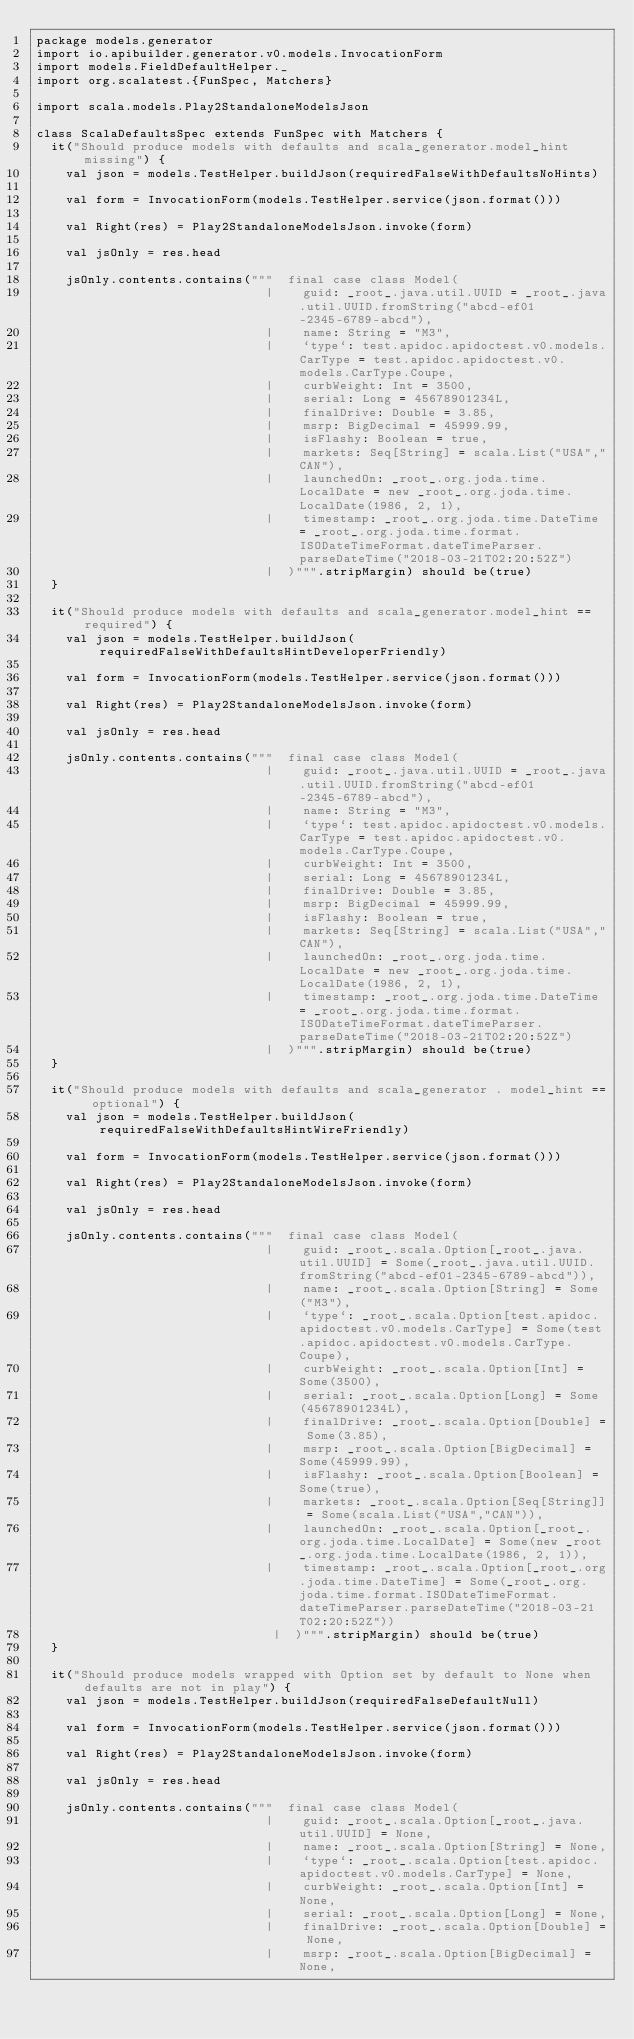Convert code to text. <code><loc_0><loc_0><loc_500><loc_500><_Scala_>package models.generator
import io.apibuilder.generator.v0.models.InvocationForm
import models.FieldDefaultHelper._
import org.scalatest.{FunSpec, Matchers}

import scala.models.Play2StandaloneModelsJson

class ScalaDefaultsSpec extends FunSpec with Matchers {
  it("Should produce models with defaults and scala_generator.model_hint missing") {
    val json = models.TestHelper.buildJson(requiredFalseWithDefaultsNoHints)

    val form = InvocationForm(models.TestHelper.service(json.format()))

    val Right(res) = Play2StandaloneModelsJson.invoke(form)

    val jsOnly = res.head

    jsOnly.contents.contains("""  final case class Model(
                               |    guid: _root_.java.util.UUID = _root_.java.util.UUID.fromString("abcd-ef01-2345-6789-abcd"),
                               |    name: String = "M3",
                               |    `type`: test.apidoc.apidoctest.v0.models.CarType = test.apidoc.apidoctest.v0.models.CarType.Coupe,
                               |    curbWeight: Int = 3500,
                               |    serial: Long = 45678901234L,
                               |    finalDrive: Double = 3.85,
                               |    msrp: BigDecimal = 45999.99,
                               |    isFlashy: Boolean = true,
                               |    markets: Seq[String] = scala.List("USA","CAN"),
                               |    launchedOn: _root_.org.joda.time.LocalDate = new _root_.org.joda.time.LocalDate(1986, 2, 1),
                               |    timestamp: _root_.org.joda.time.DateTime = _root_.org.joda.time.format.ISODateTimeFormat.dateTimeParser.parseDateTime("2018-03-21T02:20:52Z")
                               |  )""".stripMargin) should be(true)
  }

  it("Should produce models with defaults and scala_generator.model_hint == required") {
    val json = models.TestHelper.buildJson(requiredFalseWithDefaultsHintDeveloperFriendly)

    val form = InvocationForm(models.TestHelper.service(json.format()))

    val Right(res) = Play2StandaloneModelsJson.invoke(form)

    val jsOnly = res.head

    jsOnly.contents.contains("""  final case class Model(
                               |    guid: _root_.java.util.UUID = _root_.java.util.UUID.fromString("abcd-ef01-2345-6789-abcd"),
                               |    name: String = "M3",
                               |    `type`: test.apidoc.apidoctest.v0.models.CarType = test.apidoc.apidoctest.v0.models.CarType.Coupe,
                               |    curbWeight: Int = 3500,
                               |    serial: Long = 45678901234L,
                               |    finalDrive: Double = 3.85,
                               |    msrp: BigDecimal = 45999.99,
                               |    isFlashy: Boolean = true,
                               |    markets: Seq[String] = scala.List("USA","CAN"),
                               |    launchedOn: _root_.org.joda.time.LocalDate = new _root_.org.joda.time.LocalDate(1986, 2, 1),
                               |    timestamp: _root_.org.joda.time.DateTime = _root_.org.joda.time.format.ISODateTimeFormat.dateTimeParser.parseDateTime("2018-03-21T02:20:52Z")
                               |  )""".stripMargin) should be(true)
  }

  it("Should produce models with defaults and scala_generator . model_hint == optional") {
    val json = models.TestHelper.buildJson(requiredFalseWithDefaultsHintWireFriendly)

    val form = InvocationForm(models.TestHelper.service(json.format()))

    val Right(res) = Play2StandaloneModelsJson.invoke(form)

    val jsOnly = res.head

    jsOnly.contents.contains("""  final case class Model(
                               |    guid: _root_.scala.Option[_root_.java.util.UUID] = Some(_root_.java.util.UUID.fromString("abcd-ef01-2345-6789-abcd")),
                               |    name: _root_.scala.Option[String] = Some("M3"),
                               |    `type`: _root_.scala.Option[test.apidoc.apidoctest.v0.models.CarType] = Some(test.apidoc.apidoctest.v0.models.CarType.Coupe),
                               |    curbWeight: _root_.scala.Option[Int] = Some(3500),
                               |    serial: _root_.scala.Option[Long] = Some(45678901234L),
                               |    finalDrive: _root_.scala.Option[Double] = Some(3.85),
                               |    msrp: _root_.scala.Option[BigDecimal] = Some(45999.99),
                               |    isFlashy: _root_.scala.Option[Boolean] = Some(true),
                               |    markets: _root_.scala.Option[Seq[String]] = Some(scala.List("USA","CAN")),
                               |    launchedOn: _root_.scala.Option[_root_.org.joda.time.LocalDate] = Some(new _root_.org.joda.time.LocalDate(1986, 2, 1)),
                               |    timestamp: _root_.scala.Option[_root_.org.joda.time.DateTime] = Some(_root_.org.joda.time.format.ISODateTimeFormat.dateTimeParser.parseDateTime("2018-03-21T02:20:52Z"))
                                |  )""".stripMargin) should be(true)
  }

  it("Should produce models wrapped with Option set by default to None when defaults are not in play") {
    val json = models.TestHelper.buildJson(requiredFalseDefaultNull)

    val form = InvocationForm(models.TestHelper.service(json.format()))

    val Right(res) = Play2StandaloneModelsJson.invoke(form)

    val jsOnly = res.head

    jsOnly.contents.contains("""  final case class Model(
                               |    guid: _root_.scala.Option[_root_.java.util.UUID] = None,
                               |    name: _root_.scala.Option[String] = None,
                               |    `type`: _root_.scala.Option[test.apidoc.apidoctest.v0.models.CarType] = None,
                               |    curbWeight: _root_.scala.Option[Int] = None,
                               |    serial: _root_.scala.Option[Long] = None,
                               |    finalDrive: _root_.scala.Option[Double] = None,
                               |    msrp: _root_.scala.Option[BigDecimal] = None,</code> 